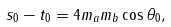<formula> <loc_0><loc_0><loc_500><loc_500>s _ { 0 } - t _ { 0 } = 4 m _ { a } m _ { b } \cos \theta _ { 0 } ,</formula> 